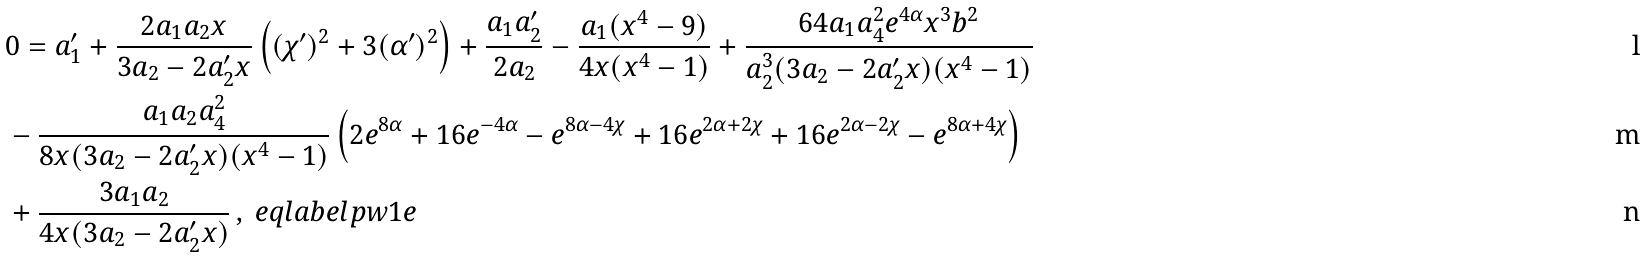Convert formula to latex. <formula><loc_0><loc_0><loc_500><loc_500>& 0 = a _ { 1 } ^ { \prime } + \frac { 2 a _ { 1 } a _ { 2 } x } { 3 a _ { 2 } - 2 a _ { 2 } ^ { \prime } x } \left ( ( \chi ^ { \prime } ) ^ { 2 } + 3 ( \alpha ^ { \prime } ) ^ { 2 } \right ) + \frac { a _ { 1 } a _ { 2 } ^ { \prime } } { 2 a _ { 2 } } - \frac { a _ { 1 } ( x ^ { 4 } - 9 ) } { 4 x ( x ^ { 4 } - 1 ) } + \frac { 6 4 a _ { 1 } a _ { 4 } ^ { 2 } e ^ { 4 \alpha } x ^ { 3 } b ^ { 2 } } { a _ { 2 } ^ { 3 } ( 3 a _ { 2 } - 2 a _ { 2 } ^ { \prime } x ) ( x ^ { 4 } - 1 ) } \\ & - \frac { a _ { 1 } a _ { 2 } a _ { 4 } ^ { 2 } } { 8 x ( 3 a _ { 2 } - 2 a _ { 2 } ^ { \prime } x ) ( x ^ { 4 } - 1 ) } \left ( 2 e ^ { 8 \alpha } + 1 6 e ^ { - 4 \alpha } - e ^ { 8 \alpha - 4 \chi } + 1 6 e ^ { 2 \alpha + 2 \chi } + 1 6 e ^ { 2 \alpha - 2 \chi } - e ^ { 8 \alpha + 4 \chi } \right ) \\ & + \frac { 3 a _ { 1 } a _ { 2 } } { 4 x ( 3 a _ { 2 } - 2 a _ { 2 } ^ { \prime } x ) } \, , \ e q l a b e l { p w 1 e }</formula> 